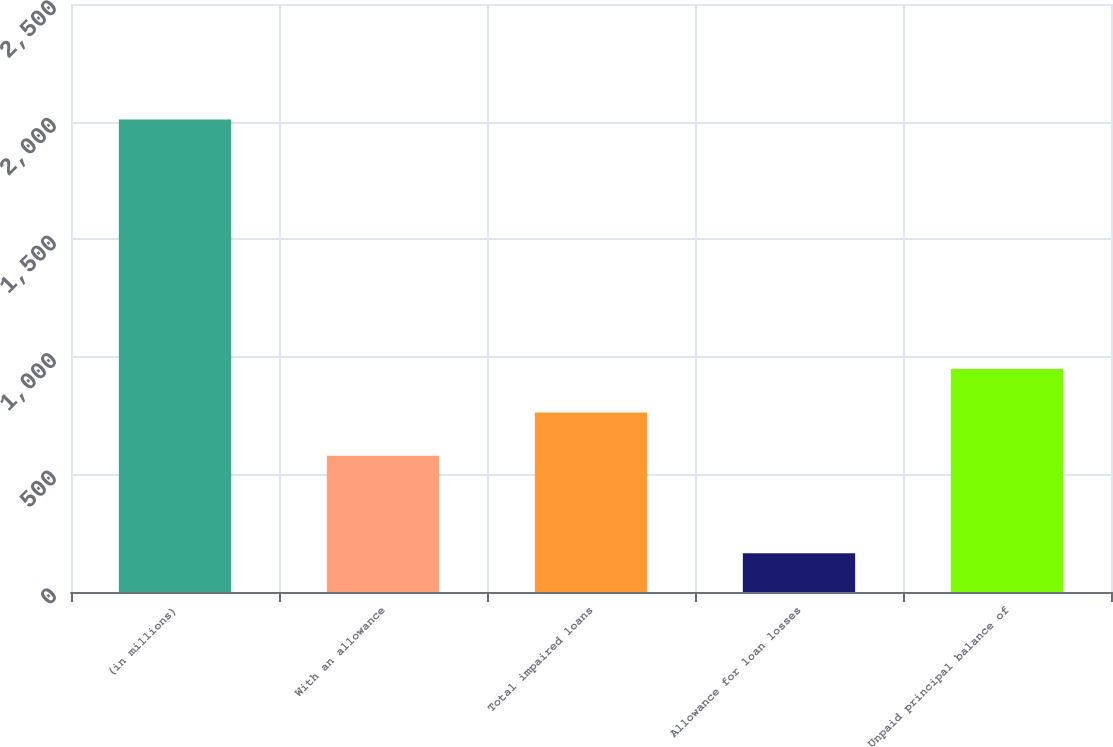Convert chart. <chart><loc_0><loc_0><loc_500><loc_500><bar_chart><fcel>(in millions)<fcel>With an allowance<fcel>Total impaired loans<fcel>Allowance for loan losses<fcel>Unpaid principal balance of<nl><fcel>2009<fcel>579<fcel>763.4<fcel>165<fcel>947.8<nl></chart> 